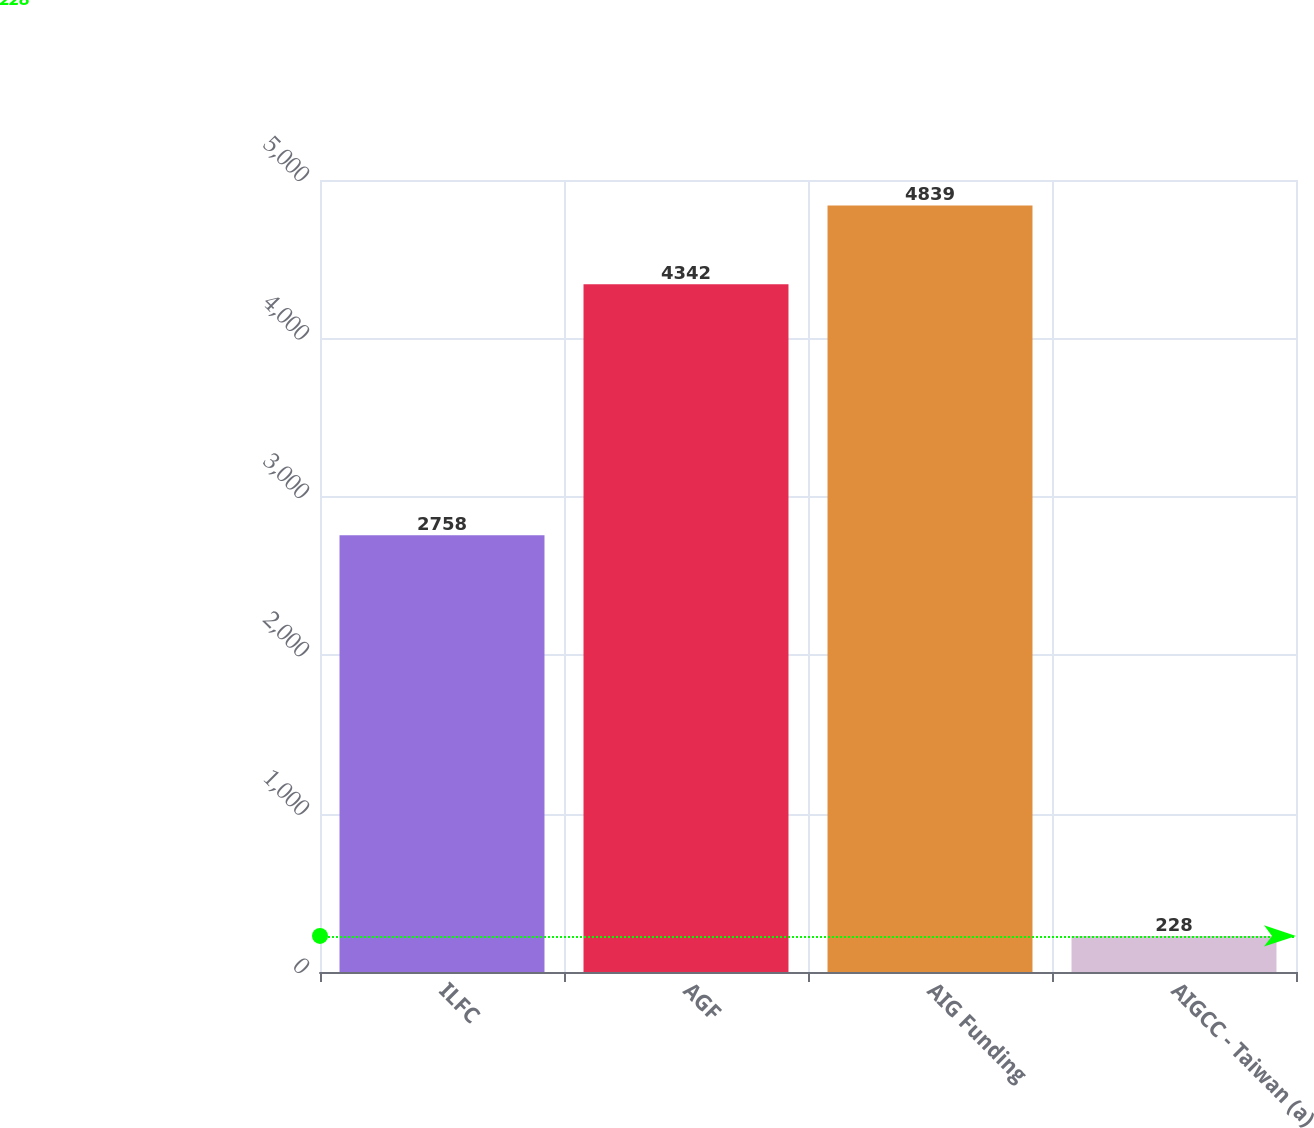Convert chart to OTSL. <chart><loc_0><loc_0><loc_500><loc_500><bar_chart><fcel>ILFC<fcel>AGF<fcel>AIG Funding<fcel>AIGCC - Taiwan (a)<nl><fcel>2758<fcel>4342<fcel>4839<fcel>228<nl></chart> 